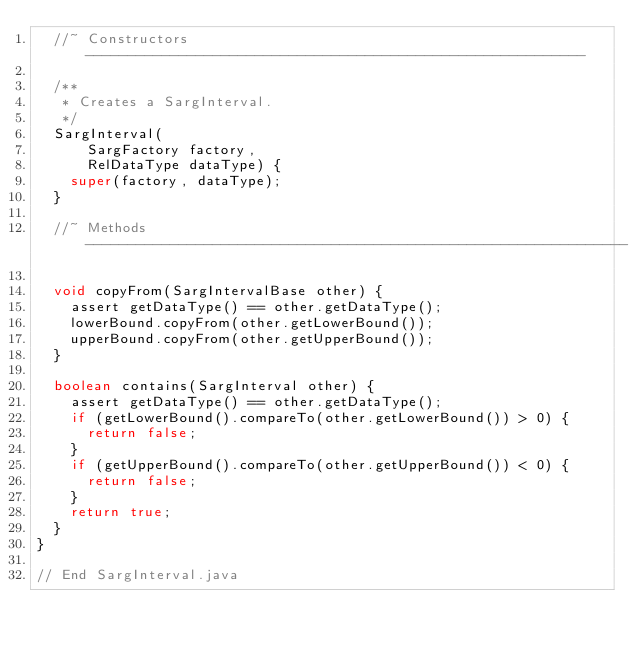Convert code to text. <code><loc_0><loc_0><loc_500><loc_500><_Java_>  //~ Constructors -----------------------------------------------------------

  /**
   * Creates a SargInterval.
   */
  SargInterval(
      SargFactory factory,
      RelDataType dataType) {
    super(factory, dataType);
  }

  //~ Methods ----------------------------------------------------------------

  void copyFrom(SargIntervalBase other) {
    assert getDataType() == other.getDataType();
    lowerBound.copyFrom(other.getLowerBound());
    upperBound.copyFrom(other.getUpperBound());
  }

  boolean contains(SargInterval other) {
    assert getDataType() == other.getDataType();
    if (getLowerBound().compareTo(other.getLowerBound()) > 0) {
      return false;
    }
    if (getUpperBound().compareTo(other.getUpperBound()) < 0) {
      return false;
    }
    return true;
  }
}

// End SargInterval.java
</code> 